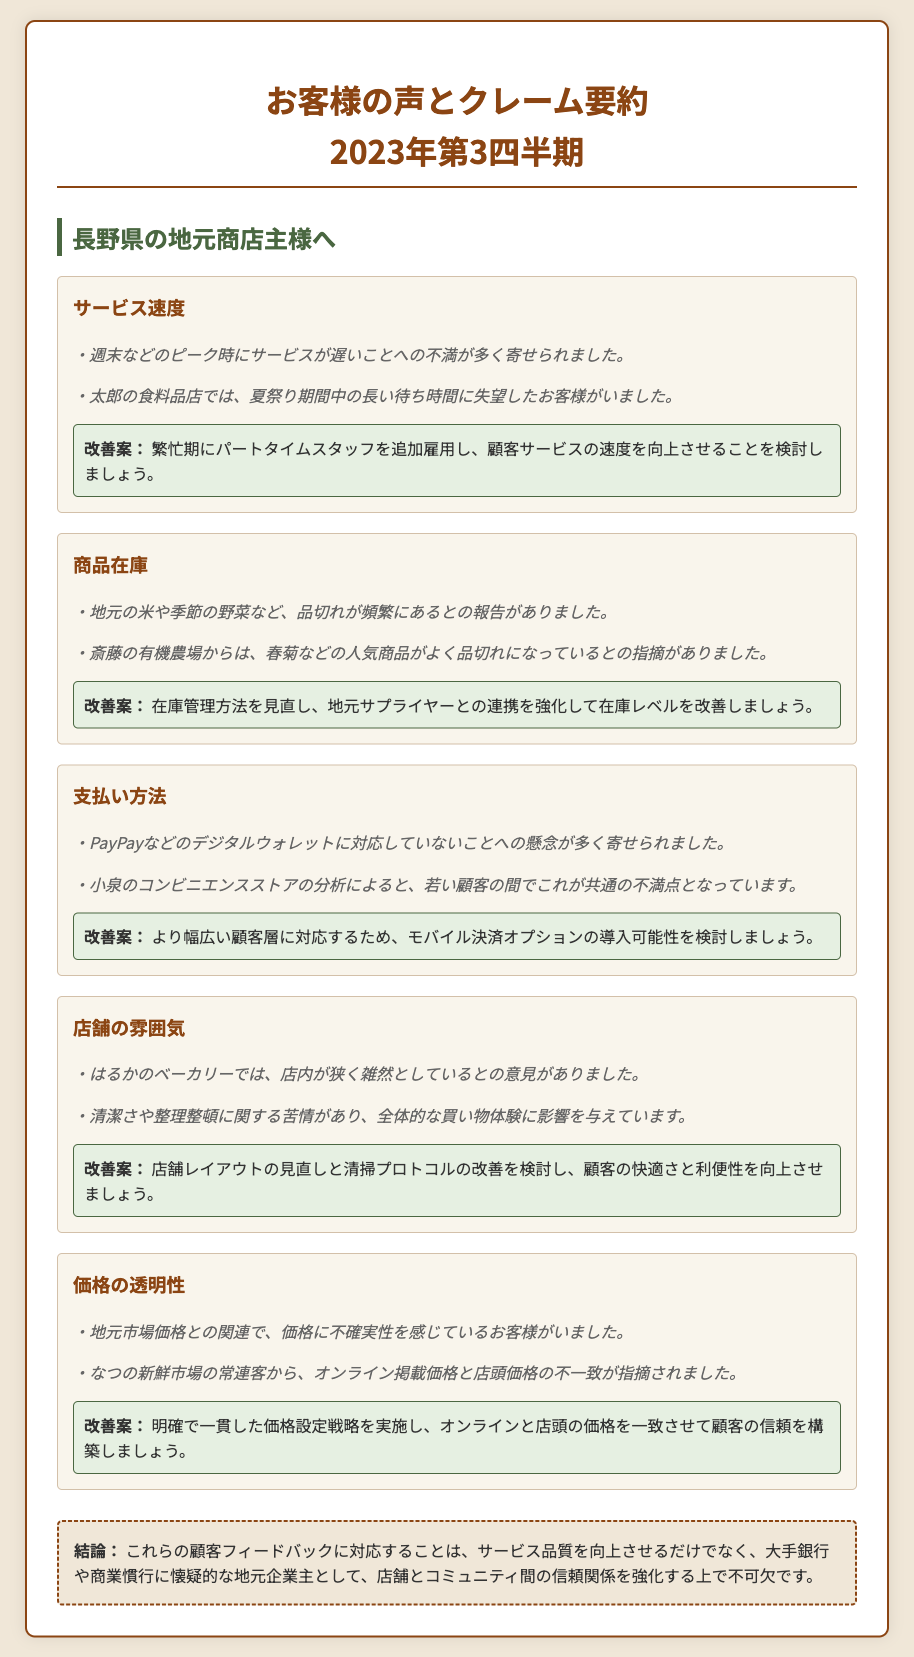What topic received complaints about long wait times? The document mentions that the service speed received complaints due to delays during peak times, particularly on weekends.
Answer: サービス速度 What specific products were noted for frequent out-of-stock issues? The document reports that local rice and seasonal vegetables frequently faced stockouts, including popular items like spring greens.
Answer: 地元の米や季節の野菜 What payment option do customers want more access to? The feedback indicated that customers are concerned about the lack of support for digital wallets like PayPay.
Answer: PayPay What is a suggested improvement for the store's atmosphere? One of the suggestions to improve the store's atmosphere is to review the layout and improve cleaning protocols.
Answer: 店舗レイアウトの見直し What was the number of complaints related to price uncertainty? The document notes that some customers felt uncertainty regarding prices compared to local market prices. However, a specific number of complaints is not stated.
Answer: 数は示されていない What is one actionable insight regarding inventory? To enhance inventory levels, the document suggests revisiting inventory management methods and strengthening connections with local suppliers.
Answer: 在庫管理方法の見直し What customer demographic is concerned about payment methods? The document highlights that young customers, particularly, have raised concerns regarding payment options.
Answer: 若い顧客 What does the conclusion emphasize regarding customer feedback? The conclusion emphasizes improving service quality through customer feedback is essential to strengthen trust between the store and the community.
Answer: 顧客の信頼を構築 